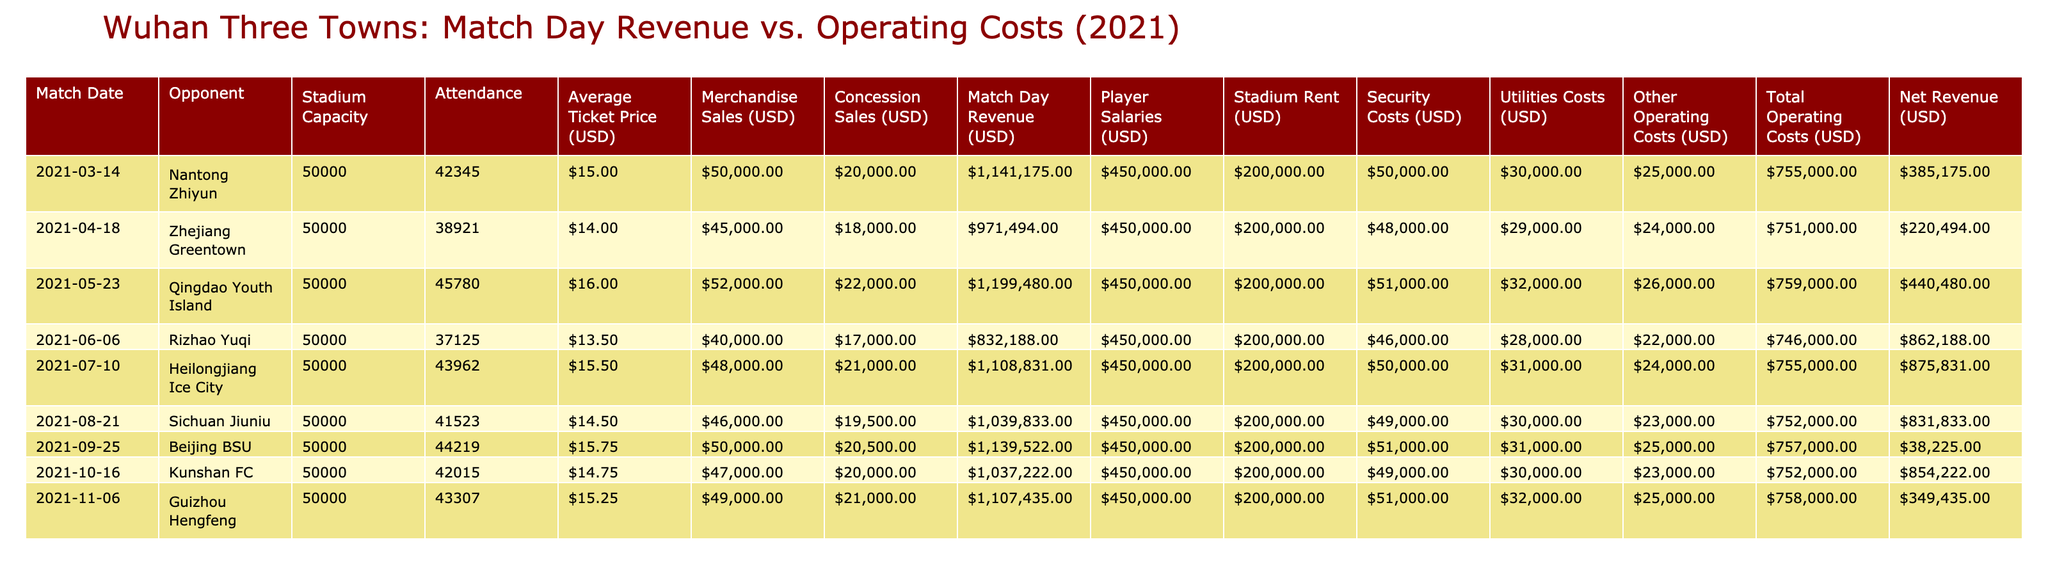What was the highest Match Day Revenue recorded in 2021? By looking at the "Match Day Revenue (USD)" column, the values are: $1,141,175; $971,494; $1,199,480; $832,188; $1,108,831; $1,039,833; $1,139,522; $1,037,222; $1,107,435. The highest value is $1,199,480 from the match against Qingdao Youth Island on May 23, 2021.
Answer: $1,199,480 What is the total net revenue for all home games in 2021? First, we need to sum the "Net Revenue (USD)" column values: $385,175 + $220,494 + $440,480 + $862,188 + $875,831 + $831,833 + $38,225 + $854,222 + $349,435 = $3,800,229. Therefore, the total net revenue is $3,800,229.
Answer: $3,800,229 Did any match result in a negative net revenue? By inspecting the "Net Revenue (USD)" column, the values are: $385,175; $220,494; $440,480; $862,188; $875,831; $831,833; $38,225; $854,222; $349,435. The lowest value is $38,225, which is a positive number, thus no matches resulted in negative net revenue.
Answer: No What was the average attendance for the home games in 2021? To calculate the average attendance, we sum the attendance values: 42,345 + 38,921 + 45,780 + 37,125 + 43,962 + 41,523 + 44,219 + 42,015 + 43,307 = 392,077. Divide this by the number of games, which is 9: 392,077 / 9 = 43,563. Therefore, the average attendance is 43,563.
Answer: 43,563 Which match had the highest total operating costs, and what was that amount? Analyzing the "Total Operating Costs (USD)" column shows the values: $755,000; $751,000; $759,000; $746,000; $755,000; $752,000; $757,000; $752,000; $758,000. The highest total operating costs were $759,000 for the match against Qingdao Youth Island on May 23, 2021.
Answer: $759,000 What was the difference between the highest and lowest merchandise sales in 2021? From the "Merchandise Sales (USD)" column, the highest value is $52,000 (Qingdao Youth Island) and the lowest is $40,000 (Heilongjiang Ice City). The difference is $52,000 - $40,000 = $12,000.
Answer: $12,000 What percentage of match day revenue was spent on operating costs in the match against Sichuan Jiuniu? In the match against Sichuan Jiuniu, the "Match Day Revenue (USD)" is $1,039,833 and the "Total Operating Costs (USD)" is $752,000. To find the percentage spent on operating costs, we calculate: ($752,000 / $1,039,833) * 100 = approximately 72.22%.
Answer: 72.22% What was the average ticket price across all matches? The "Average Ticket Price (USD)" values are: $15.00; $14.00; $16.00; $13.50; $15.50; $14.50; $15.75; $14.75; $15.25. Summing these gives $15.00 + $14.00 + $16.00 + $13.50 + $15.50 + $14.50 + $15.75 + $14.75 + $15.25 = $14.75. Divided by the number of matches (9), the average ticket price is approximately $15.00.
Answer: $15.00 